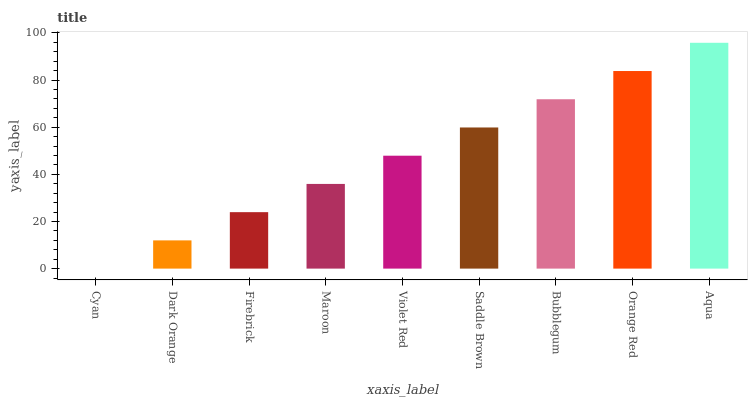Is Cyan the minimum?
Answer yes or no. Yes. Is Aqua the maximum?
Answer yes or no. Yes. Is Dark Orange the minimum?
Answer yes or no. No. Is Dark Orange the maximum?
Answer yes or no. No. Is Dark Orange greater than Cyan?
Answer yes or no. Yes. Is Cyan less than Dark Orange?
Answer yes or no. Yes. Is Cyan greater than Dark Orange?
Answer yes or no. No. Is Dark Orange less than Cyan?
Answer yes or no. No. Is Violet Red the high median?
Answer yes or no. Yes. Is Violet Red the low median?
Answer yes or no. Yes. Is Orange Red the high median?
Answer yes or no. No. Is Dark Orange the low median?
Answer yes or no. No. 